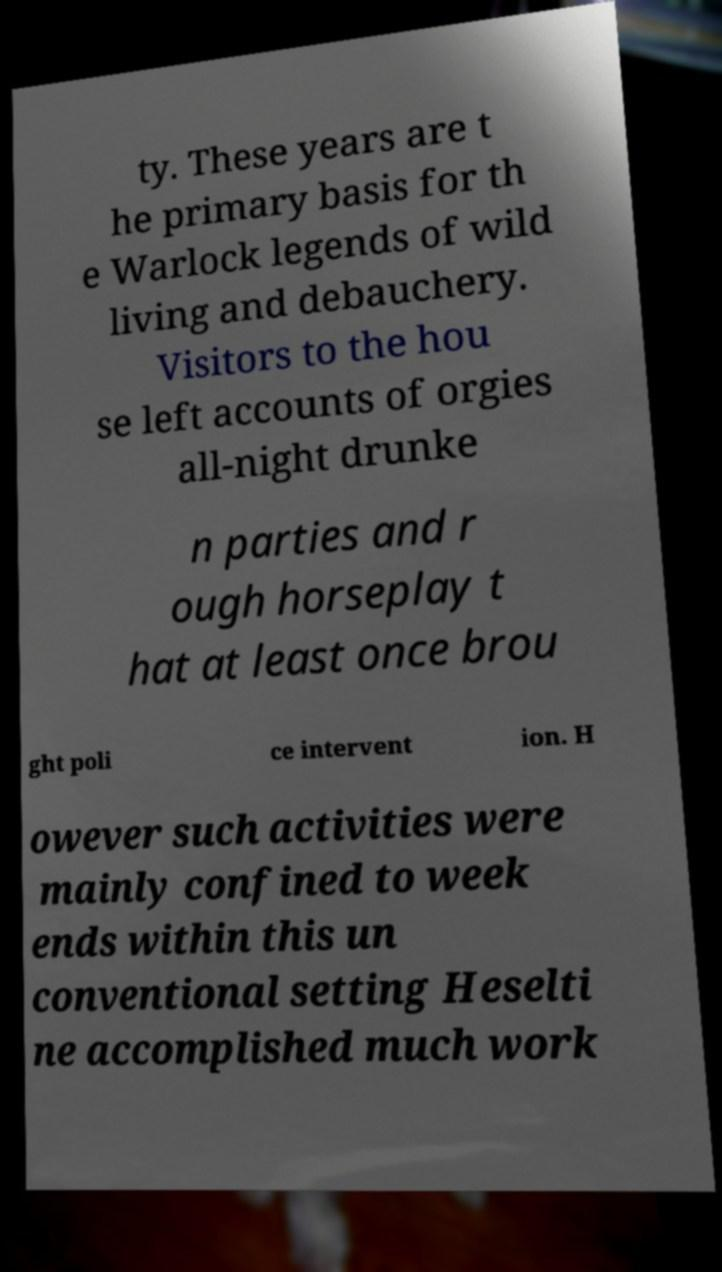What messages or text are displayed in this image? I need them in a readable, typed format. ty. These years are t he primary basis for th e Warlock legends of wild living and debauchery. Visitors to the hou se left accounts of orgies all-night drunke n parties and r ough horseplay t hat at least once brou ght poli ce intervent ion. H owever such activities were mainly confined to week ends within this un conventional setting Heselti ne accomplished much work 